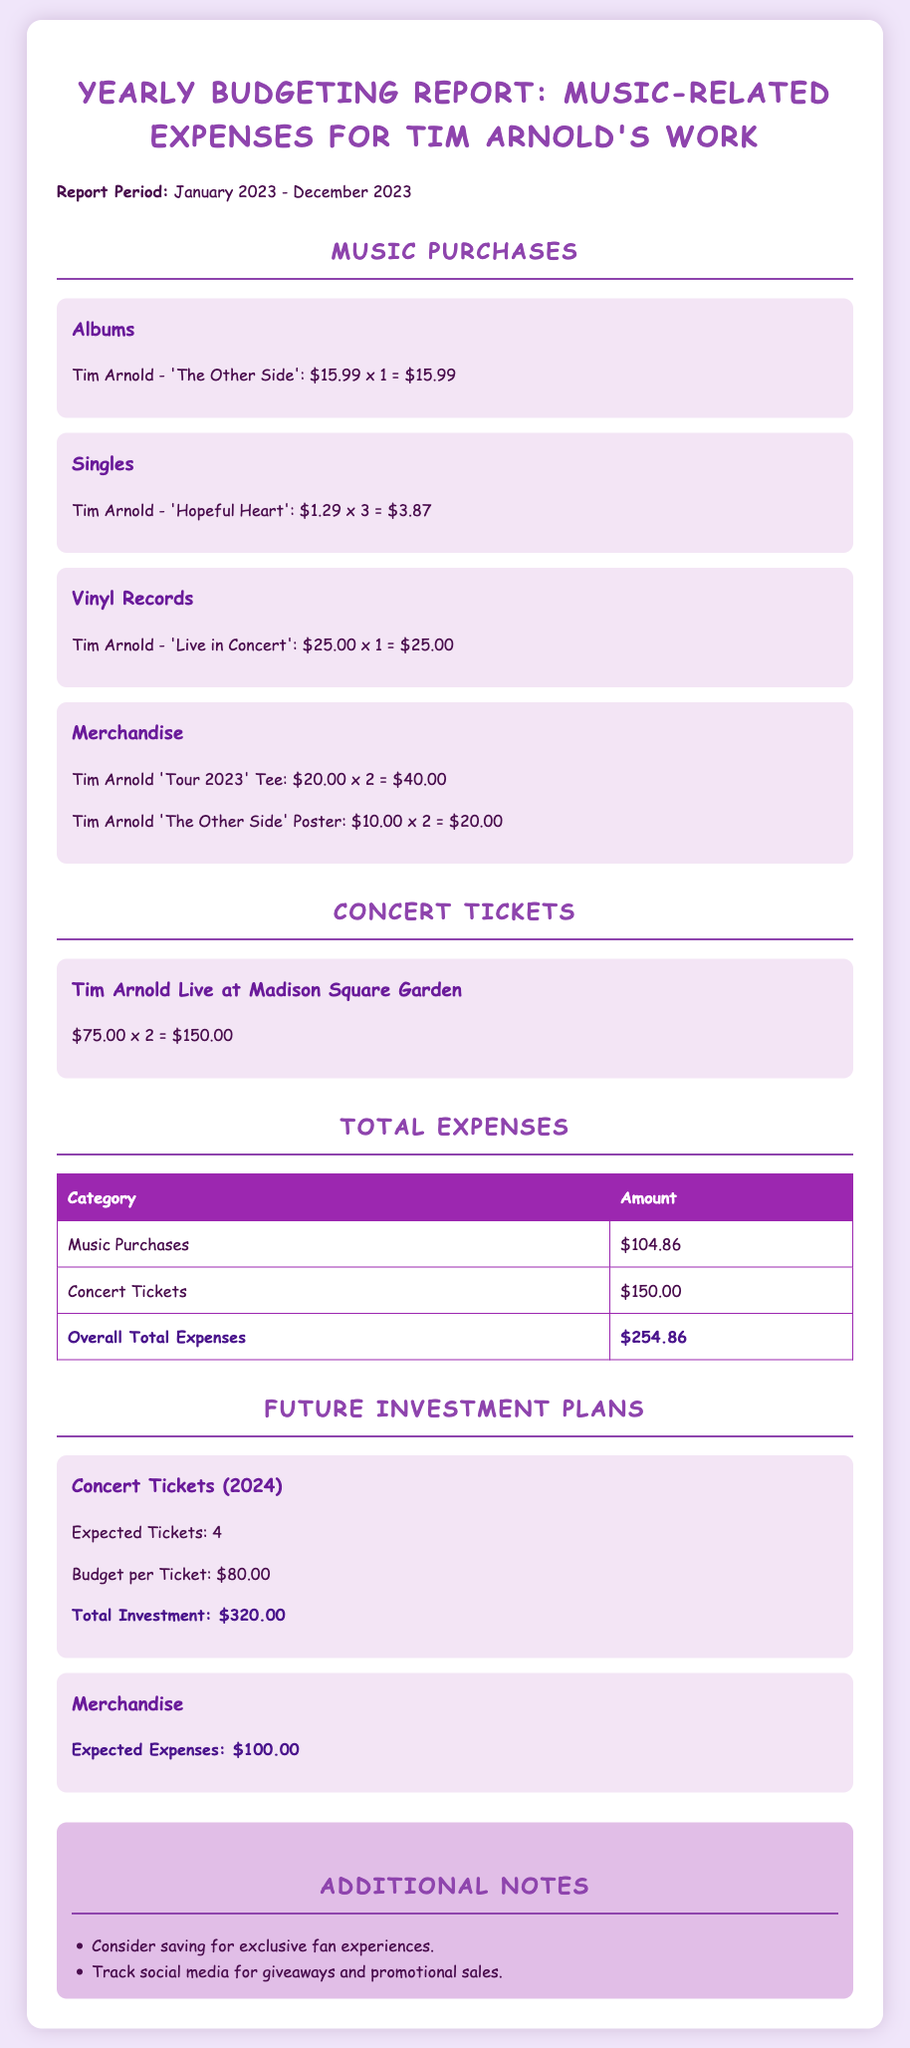What is the total amount spent on music purchases? The total amount for music purchases is detailed in the document as $104.86.
Answer: $104.86 How many singles of 'Hopeful Heart' were purchased? The document states that 3 singles of 'Hopeful Heart' were purchased at $1.29 each.
Answer: 3 What is the cost of the 'Live in Concert' vinyl record? The cost of the 'Live in Concert' vinyl record is listed as $25.00 in the document.
Answer: $25.00 What is the overall total of expenses? The overall total expenses are calculated to be $254.86 in the report.
Answer: $254.86 How many concert tickets are planned for 2024? The document indicates that there are expected tickets for 2024, totaling 4.
Answer: 4 What is the expected budget per concert ticket for 2024? The expected budget per concert ticket for 2024 is noted as $80.00.
Answer: $80.00 What merchandise is included in the music purchases? The included merchandise comprises a 'Tour 2023' Tee and 'The Other Side' Poster.
Answer: 'Tour 2023' Tee and 'The Other Side' Poster What is the expected future expense for merchandise? The expected future expense for merchandise is specified as $100.00.
Answer: $100.00 What concert is mentioned in the concert tickets section? The concert mentioned is Tim Arnold Live at Madison Square Garden.
Answer: Tim Arnold Live at Madison Square Garden 